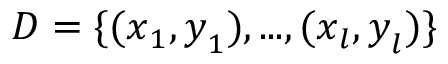Convert formula to latex. <formula><loc_0><loc_0><loc_500><loc_500>D = \{ ( x _ { 1 } , y _ { 1 } ) , \dots , ( x _ { l } , y _ { l } ) \}</formula> 